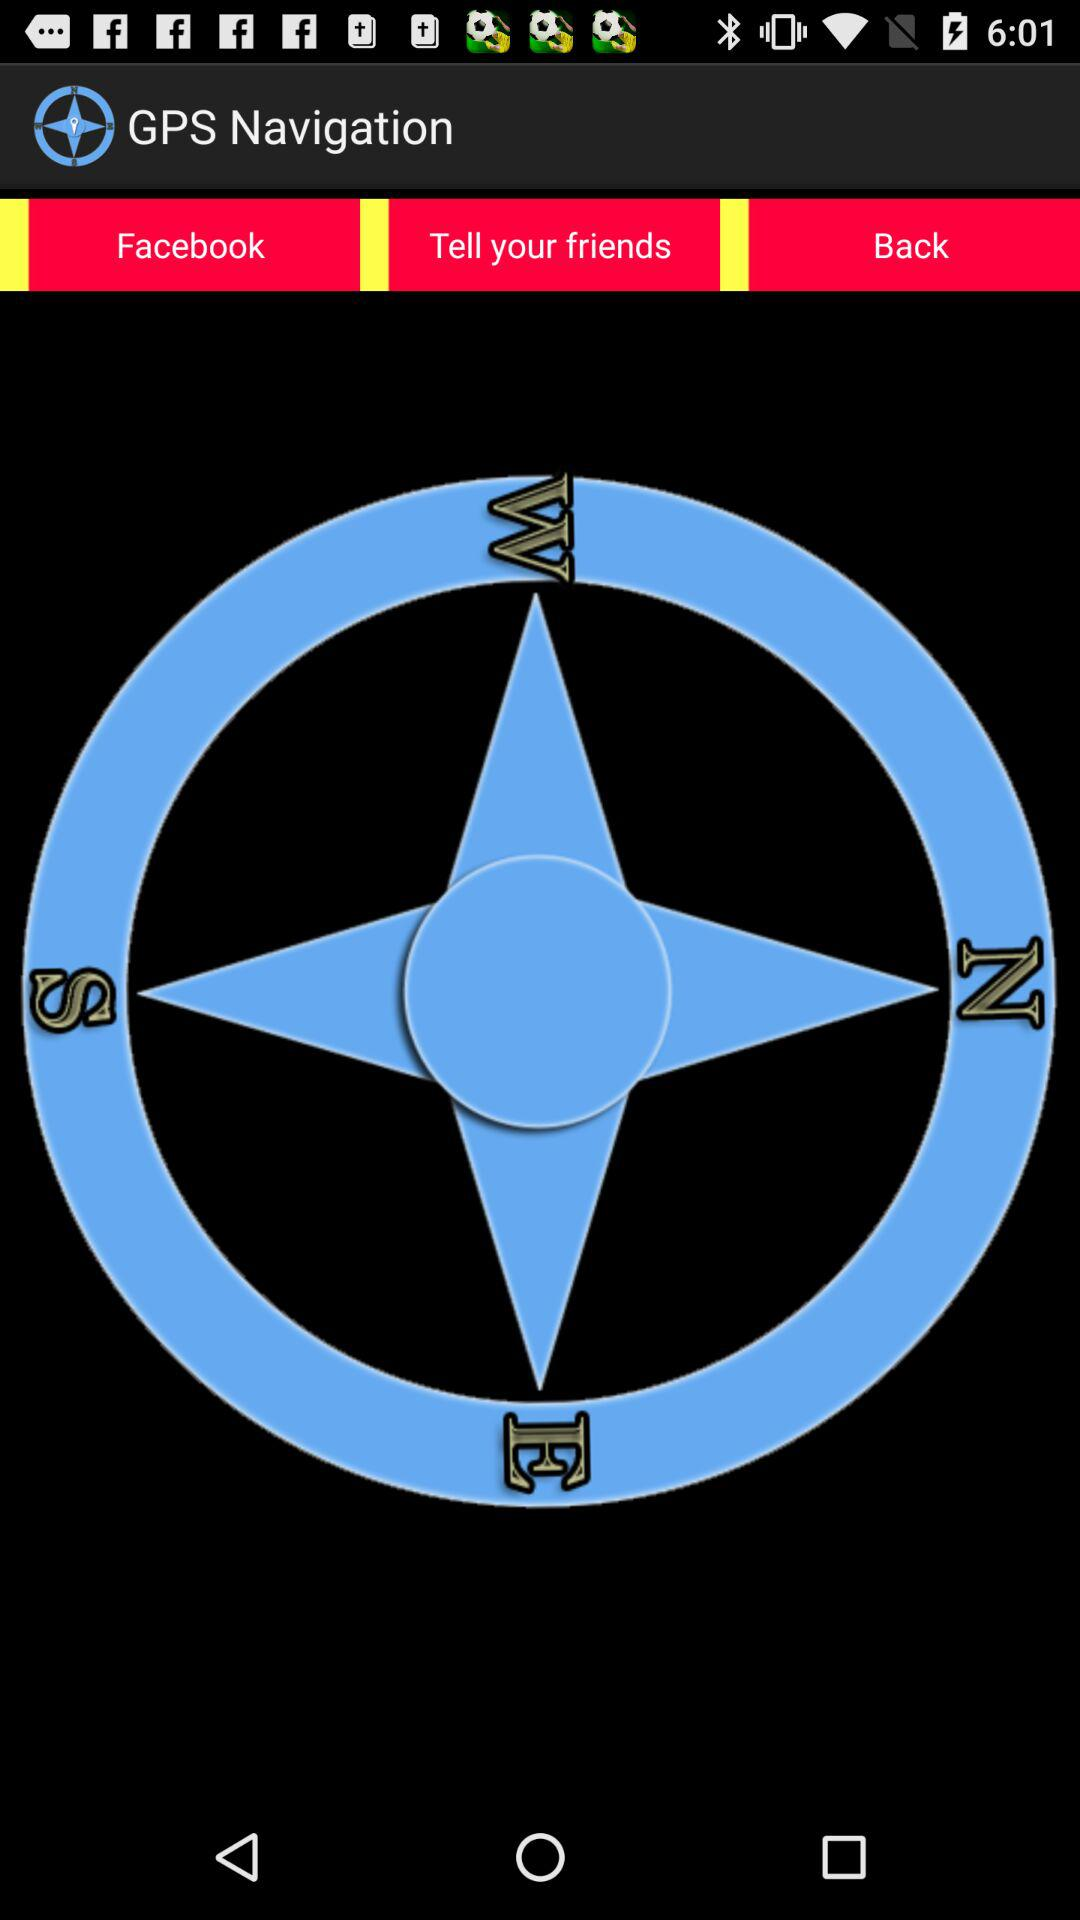What is the application name? The application name is "GPS Navigation". 